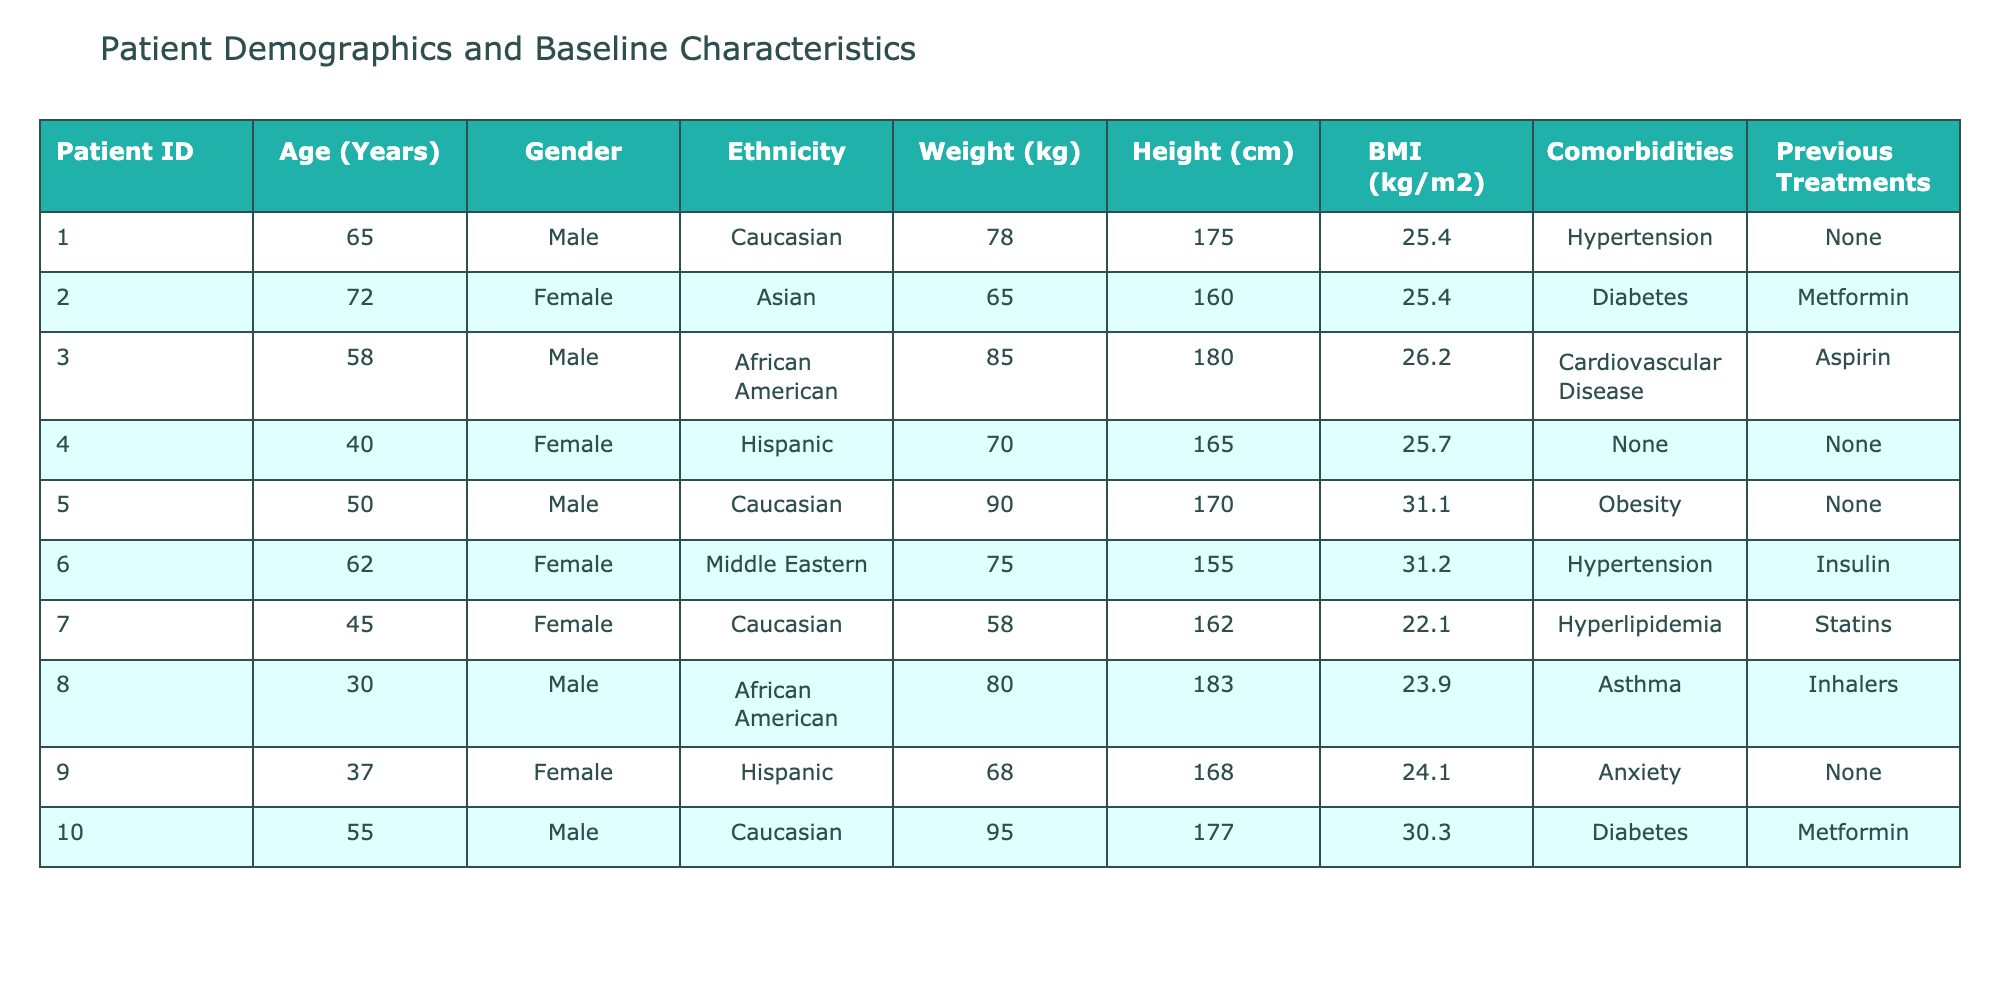What is the age of the oldest patient in the trial? By scanning the "Age (Years)" column, I observe the highest value listed is 72. Thus, the oldest patient is 72 years old.
Answer: 72 How many patients have Hypertension as a comorbidity? I can see that the "Comorbidities" column lists Hypertension for two patients (IDs 1 and 6). Thus, the total count of patients with Hypertension is two.
Answer: 2 What is the average BMI of female patients in the trial? The BMI values for female patients are 25.4, 31.2, 22.1, 24.1. Adding these gives a total of 103.0. Since there are 4 female patients, the average BMI is 103.0/4 = 25.75.
Answer: 25.75 Is there any patient in the trial who reports multiple comorbidities? Reviewing the "Comorbidities" column, all recorded patients have reported either one or no comorbidities; therefore, no patients report multiple comorbidities in this trial.
Answer: No What is the average weight of male patients in the trial? For male patients, their weights are 78, 85, 90, 80, 95. Summing these gives 428 kg. There are 5 male patients, so the average weight is 428/5 = 85.6 kg.
Answer: 85.6 Which ethnicity has the highest average weight among patients? Grouping the patients by ethnicity: Caucasian patients weigh 78, 90, 95 (average 87.67 kg), African American patients weigh 85, 80 (average 82.5 kg), Hispanic patients weigh 70, 68 (average 69 kg), and Asian patients weigh 65 (only 1 patient). Therefore, the highest average weight is for Caucasian patients at 87.67 kg.
Answer: Caucasian Does any patient have a BMI greater than 30 and also has Diabetes? Looking at the table, patients with diabetes (IDs 2 and 10) have BMIs of 25.4 and 30.3 respectively. Since only ID 10 exceeds 30, the answer is yes, one patient meets both criteria.
Answer: Yes What percentage of patients are female in this trial? There are 10 patients total, with 4 of them being female. Hence, the percentage is (4/10)*100 = 40%.
Answer: 40% 